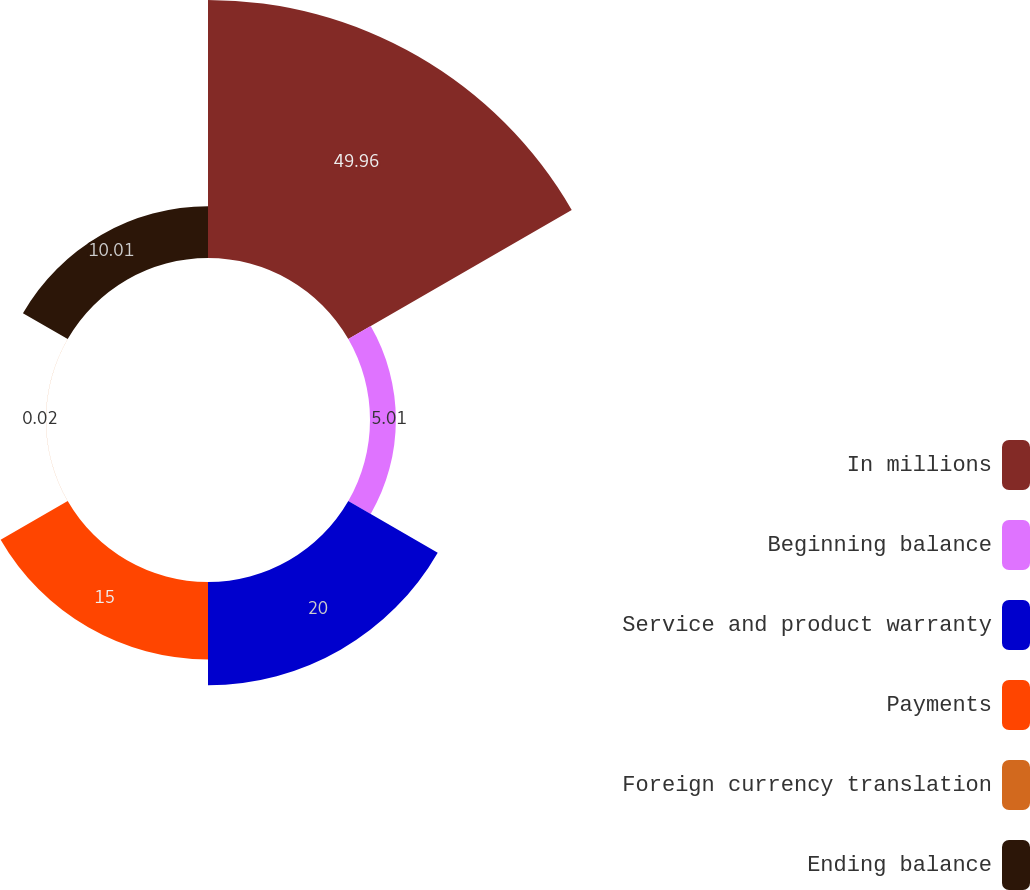Convert chart to OTSL. <chart><loc_0><loc_0><loc_500><loc_500><pie_chart><fcel>In millions<fcel>Beginning balance<fcel>Service and product warranty<fcel>Payments<fcel>Foreign currency translation<fcel>Ending balance<nl><fcel>49.97%<fcel>5.01%<fcel>20.0%<fcel>15.0%<fcel>0.02%<fcel>10.01%<nl></chart> 